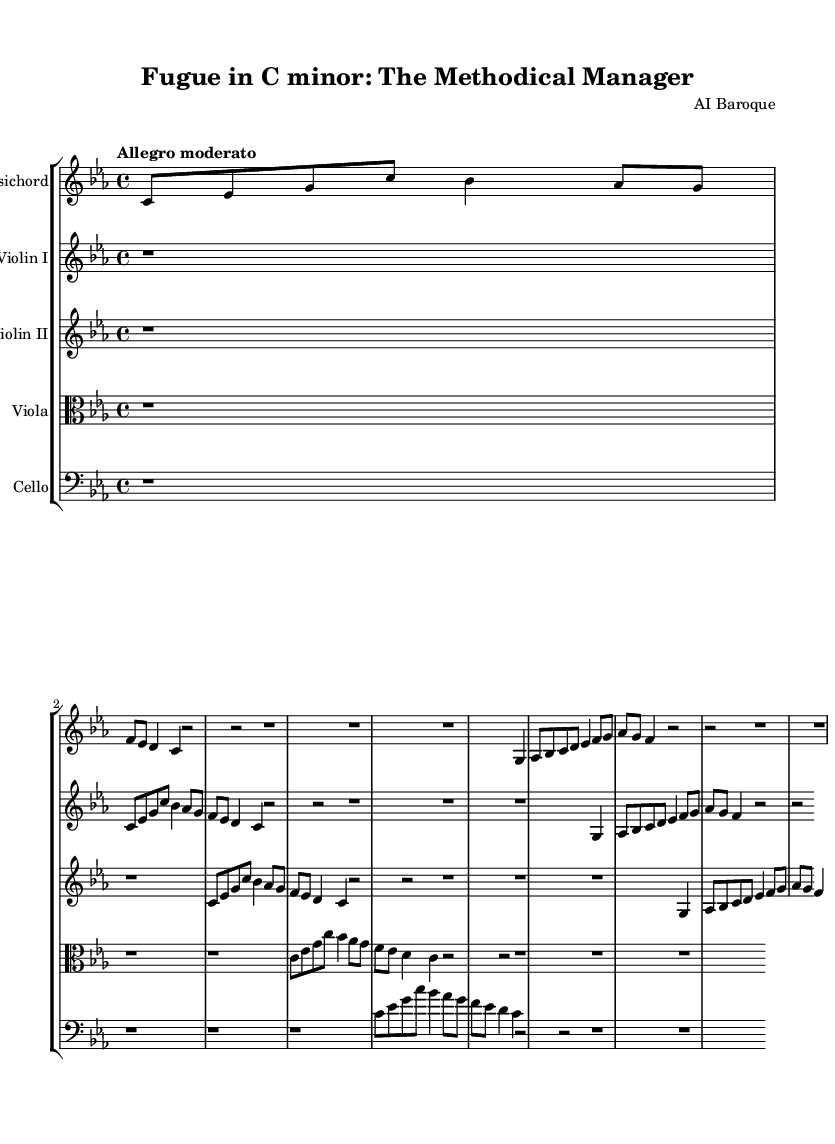What is the key signature of this music? The key signature is indicated at the beginning of the score, and it shows four flats. Therefore, the key signature corresponds to C minor, which is derived from the scale containing B flat, E flat, A flat, and D flat.
Answer: C minor What is the time signature of this music? The time signature is found at the beginning of the score, presented as a fraction. Here, it is shown as 4/4, which means there are four beats in each measure and the quarter note receives one beat.
Answer: 4/4 What is the tempo marking for this piece? The tempo marking is indicated above the music staff and describes the speed of the piece. It states “Allegro moderato,” which suggests a moderately fast tempo.
Answer: Allegro moderato How many instruments are featured in this composition? The score lists each instrument under their respective staff. Counting these, we find that there are five distinct instruments: harpsichord, violin I, violin II, viola, and cello.
Answer: Five What is the primary theme of the fugue? The primary theme or subject is explicitly stated at the start of the harpsichord part. It begins with a clear melodic line that outlines the notes: C, E flat, G, C, B flat, and so on. Thus, this sets the thematic material for the composition.
Answer: C, E flat, G How is the countersubject structured in relation to the subject? The countersubject is introduced after the subject in the harpsichord part. It is characterized as a contrasting melodic line that interlocks with the subject, often appearing in a different voice and supporting the harmonic structure.
Answer: Contrasting interlocking line What compositional technique is primarily used in this fugue? The primary technique in a fugue is imitation, where the main theme (subject) is introduced by one voice and is subsequently echoed by others at different pitches or in different registrations. This compositional method is foundational to the fugue structure.
Answer: Imitation 